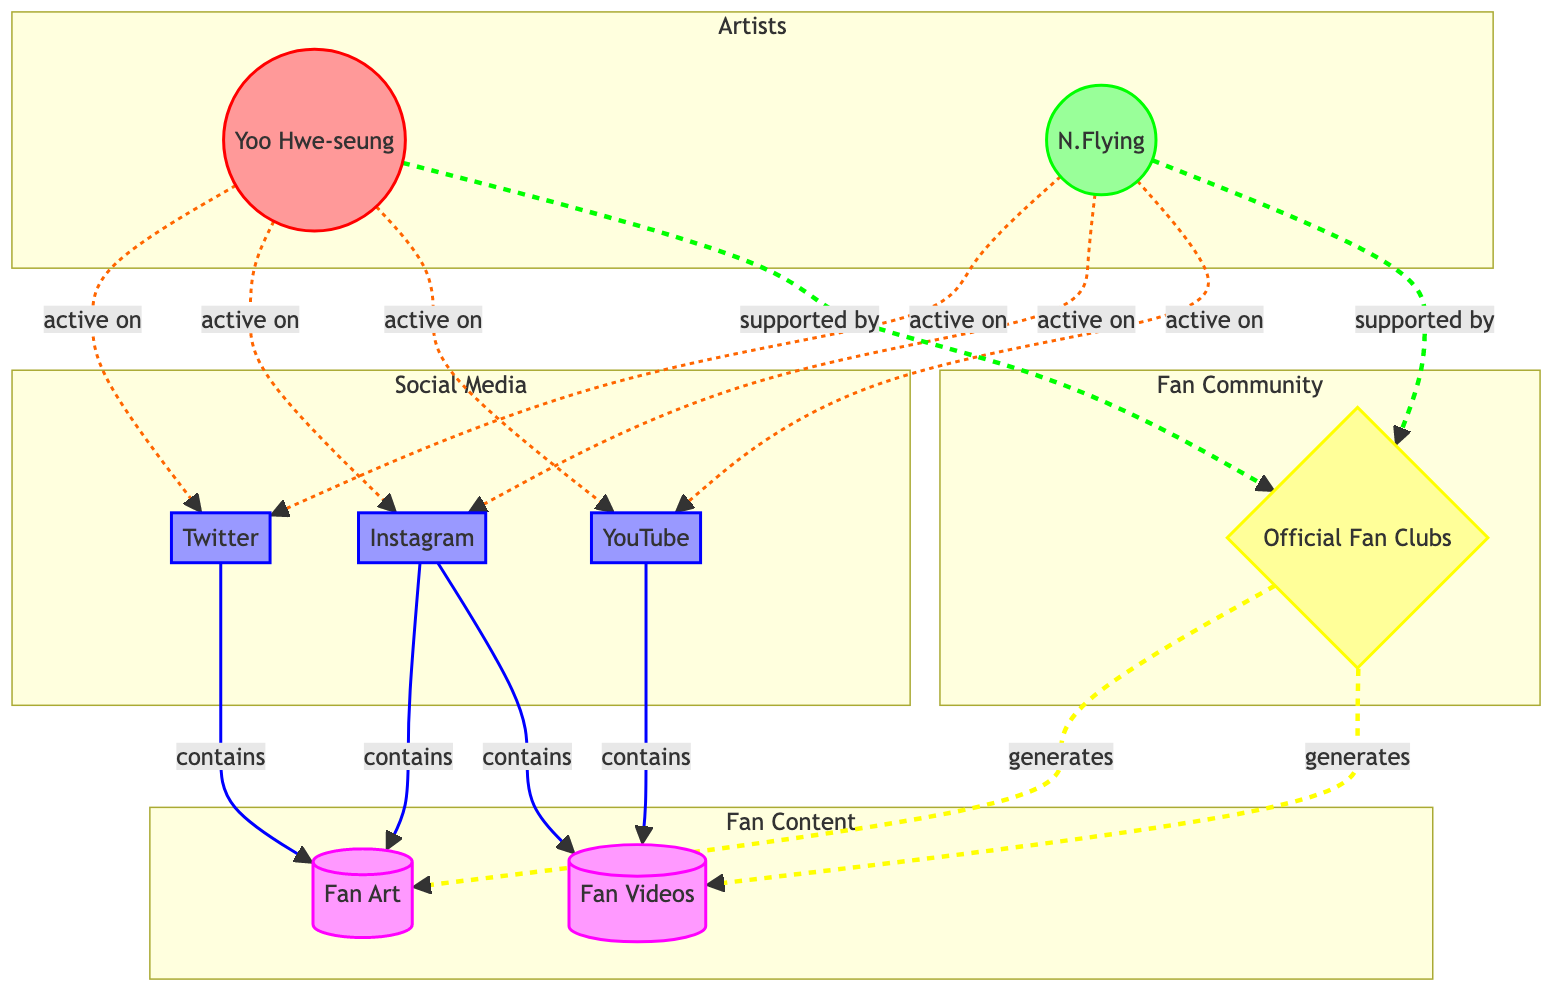What artists are active on Twitter? The diagram shows that both Yoo Hwe-seung and N.Flying have an edge labeled "active_on" connecting them to the Twitter node, indicating their presence on this platform.
Answer: Yoo Hwe-seung, N.Flying How many social media platforms are represented in the diagram? The nodes for social media in the diagram are Twitter, Instagram, and YouTube. Counting these nodes gives us a total of three social media platforms.
Answer: 3 What type of content is generated by Official Fan Clubs? The edges from the Official Fan Clubs node indicate that they generate both Fan Art and Fan Videos, as shown by the edges labeled "generates".
Answer: Fan Art, Fan Videos Which social media platform contains Fan Videos? According to the diagram, Fan Videos are contained in both the YouTube and Instagram nodes, as indicated by the edges labeled "contains".
Answer: YouTube, Instagram What is the relationship between Yoo Hwe-seung and Official Fan Clubs? In the diagram, there is an edge labeled "supported_by" connecting Yoo Hwe-seung to the Official Fan Clubs node, indicating that Yoo Hwe-seung is supported by these fan communities.
Answer: supported_by How many artists and bands are shown in the diagram? The diagram includes two distinct nodes labeled as artist and band, specifically Yoo Hwe-seung as the artist and N.Flying as the band, giving a total of two.
Answer: 2 Which social media platform is associated with the most content types? Analyzing the edges, Instagram connects to both Fan Art and Fan Videos, while other social media platforms are each associated with either one or two content types; hence, Instagram is associated with the most.
Answer: Instagram How many edges are labeled "active_on"? Counting the edges labeled "active_on" in the diagram, there are a total of six connections from these artists to the social media platforms indicating their activity on these platforms.
Answer: 6 